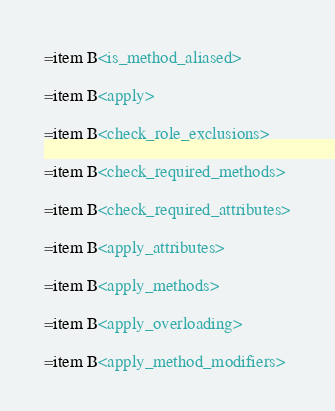<code> <loc_0><loc_0><loc_500><loc_500><_Perl_>
=item B<is_method_aliased>

=item B<apply>

=item B<check_role_exclusions>

=item B<check_required_methods>

=item B<check_required_attributes>

=item B<apply_attributes>

=item B<apply_methods>

=item B<apply_overloading>

=item B<apply_method_modifiers>
</code> 